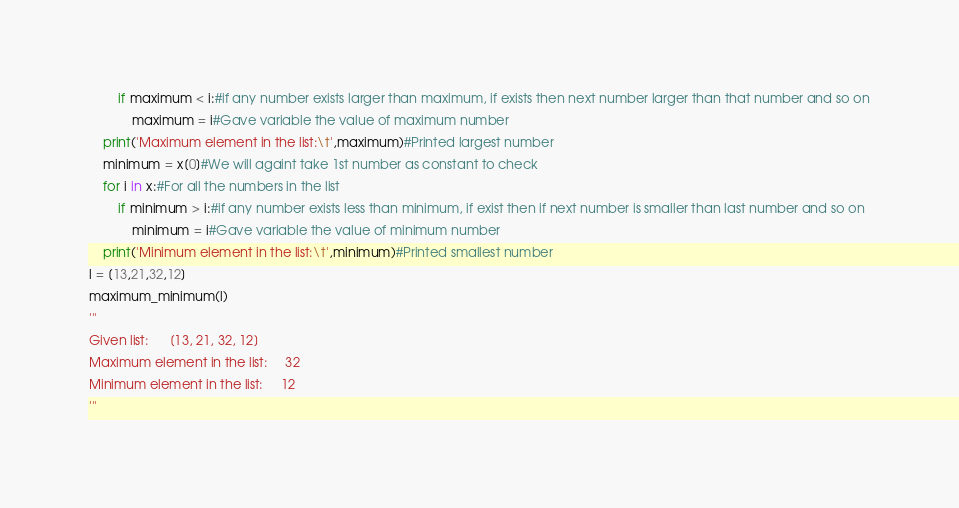Convert code to text. <code><loc_0><loc_0><loc_500><loc_500><_Python_>        if maximum < i:#if any number exists larger than maximum, if exists then next number larger than that number and so on
            maximum = i#Gave variable the value of maximum number
    print('Maximum element in the list:\t',maximum)#Printed largest number
    minimum = x[0]#We will againt take 1st number as constant to check
    for i in x:#For all the numbers in the list
        if minimum > i:#if any number exists less than minimum, if exist then if next number is smaller than last number and so on
            minimum = i#Gave variable the value of minimum number
    print('Minimum element in the list:\t',minimum)#Printed smallest number
l = [13,21,32,12]
maximum_minimum(l)
'''
Given list:      [13, 21, 32, 12]
Maximum element in the list:     32
Minimum element in the list:     12
'''
</code> 